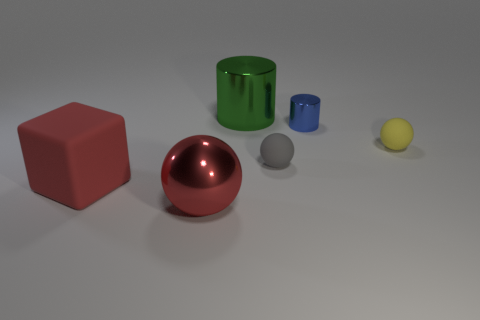Add 4 small gray objects. How many objects exist? 10 Subtract all blocks. How many objects are left? 5 Subtract all shiny spheres. Subtract all red rubber blocks. How many objects are left? 4 Add 6 big metallic balls. How many big metallic balls are left? 7 Add 4 small gray things. How many small gray things exist? 5 Subtract 1 gray spheres. How many objects are left? 5 